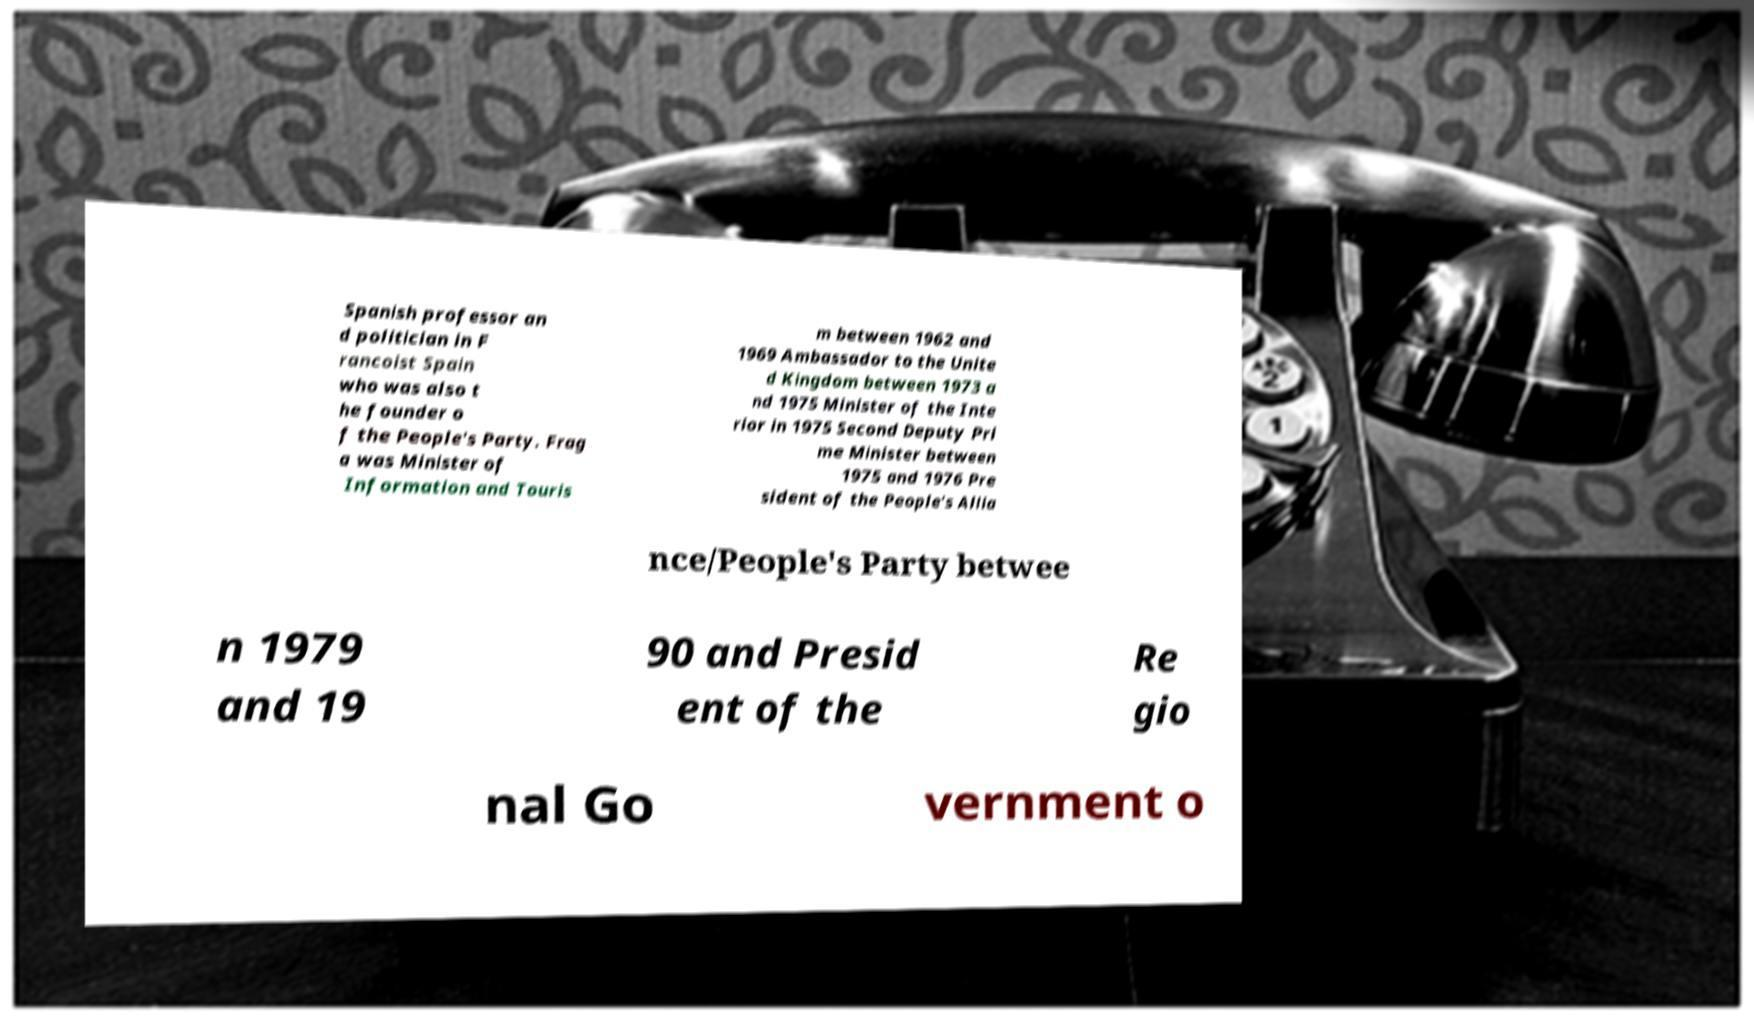What messages or text are displayed in this image? I need them in a readable, typed format. Spanish professor an d politician in F rancoist Spain who was also t he founder o f the People's Party. Frag a was Minister of Information and Touris m between 1962 and 1969 Ambassador to the Unite d Kingdom between 1973 a nd 1975 Minister of the Inte rior in 1975 Second Deputy Pri me Minister between 1975 and 1976 Pre sident of the People's Allia nce/People's Party betwee n 1979 and 19 90 and Presid ent of the Re gio nal Go vernment o 